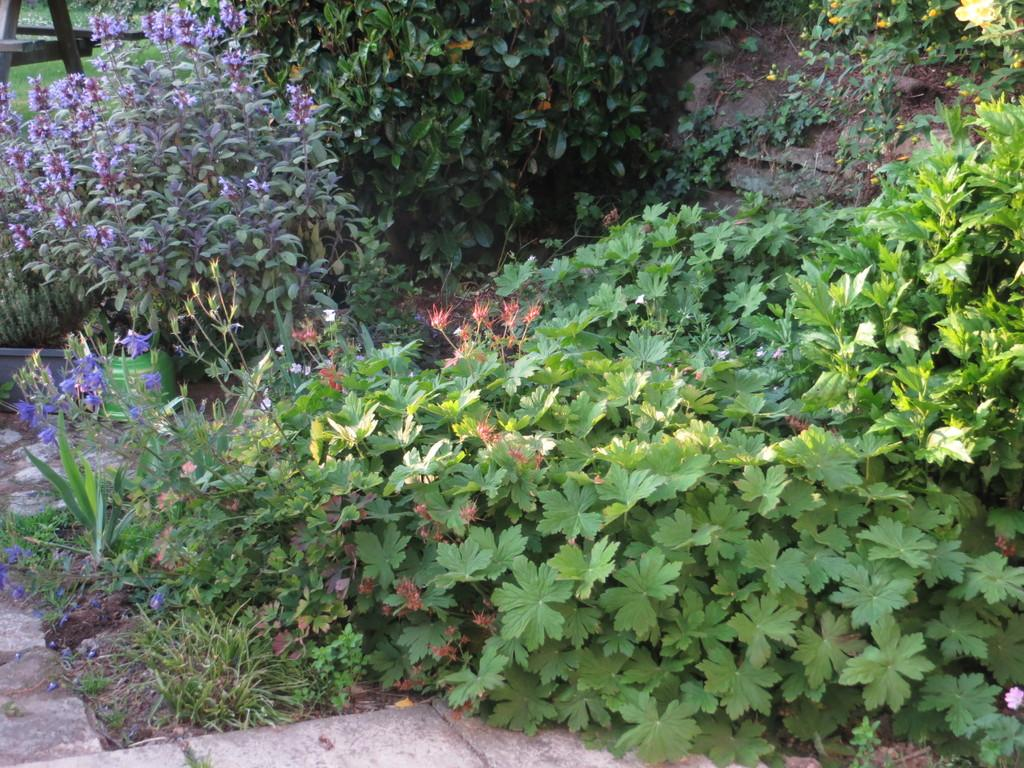What type of living organisms can be seen in the image? Plants can be seen in the image. Where are the flowers located in the image? The flowers are on the top left of the image. What can be used for walking or traversing in the image? There is a path visible in the image. What type of toothpaste is being used by the toad in the image? There is no toad or toothpaste present in the image. 